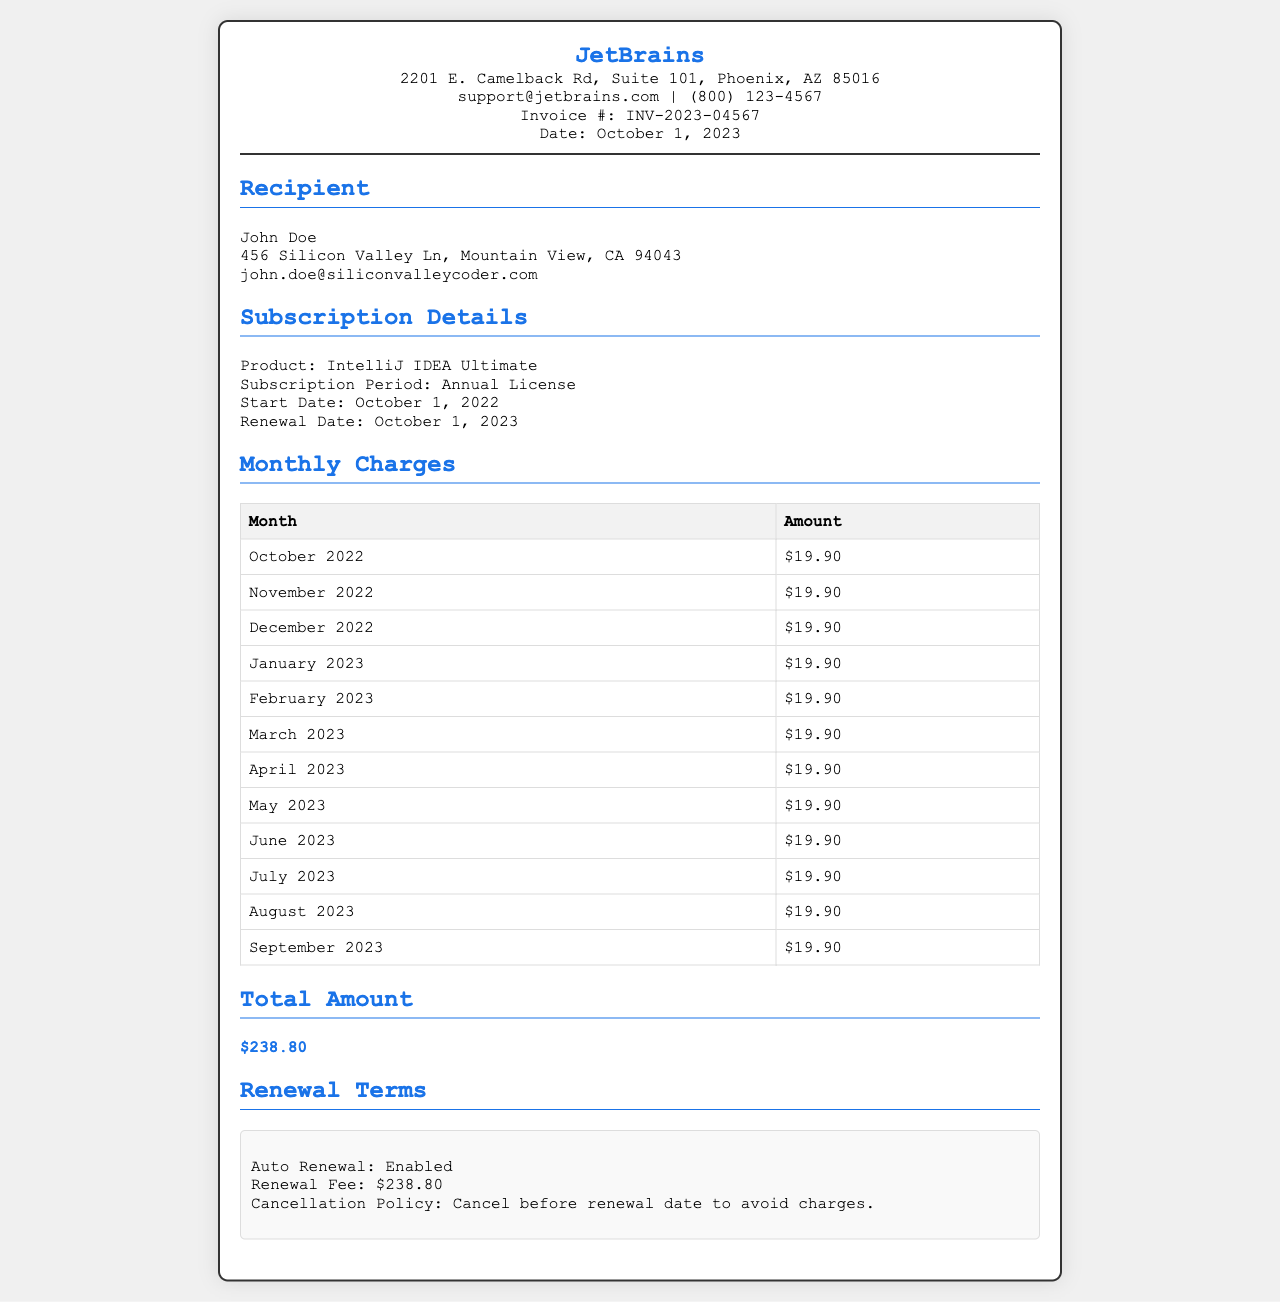What is the invoice number? The invoice number is clearly shown in the document as a unique identifier for this receipt.
Answer: INV-2023-04567 What is the total amount charged? The total amount is displayed in the total section of the receipt, summarizing the monthly charges.
Answer: $238.80 What is the subscription start date? The start date of the subscription is mentioned under Subscription Details, outlining when the license began.
Answer: October 1, 2022 How much is charged per month? Each monthly charge is listed in the Monthly Charges table, showing consistent pricing throughout the months.
Answer: $19.90 When is the renewal date? The renewal date indicates when the next payment will automatically occur, listed in the Subscription Details section.
Answer: October 1, 2023 What product is being licensed? The product being licensed is specified in the Subscription Details, indicating the software associated with the receipt.
Answer: IntelliJ IDEA Ultimate Is auto-renewal enabled? The renewal terms explicitly state whether the subscription will automatically renew or not.
Answer: Enabled What is the cancellation policy? The cancellation policy informs users about how to avoid future charges, as stated in the renewal terms.
Answer: Cancel before renewal date to avoid charges 